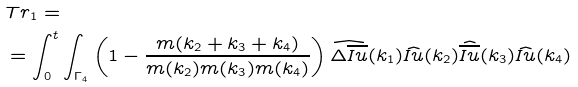Convert formula to latex. <formula><loc_0><loc_0><loc_500><loc_500>& T r _ { 1 } = \\ & = \int _ { 0 } ^ { t } \int _ { \Gamma _ { 4 } } \left ( 1 - \frac { m ( k _ { 2 } + k _ { 3 } + k _ { 4 } ) } { m ( k _ { 2 } ) m ( k _ { 3 } ) m ( k _ { 4 } ) } \right ) \widehat { \Delta \overline { I u } } ( k _ { 1 } ) \widehat { I u } ( k _ { 2 } ) \widehat { \overline { I u } } ( k _ { 3 } ) \widehat { I u } ( k _ { 4 } )</formula> 